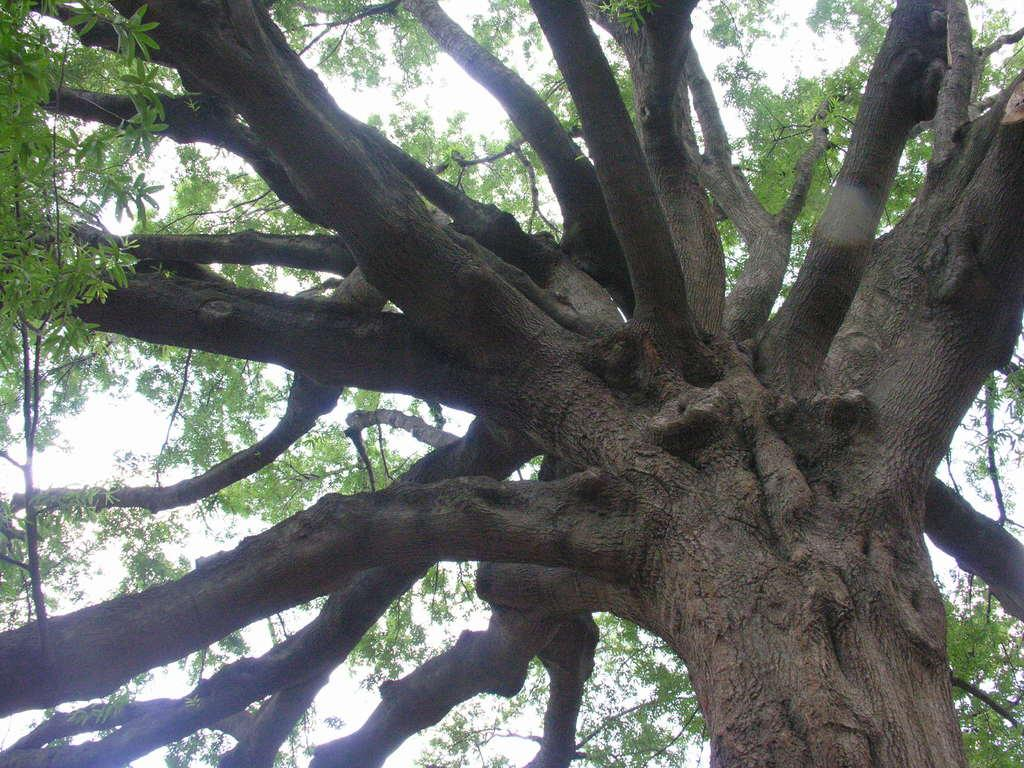What can be seen at the top of the image? The sky is visible in the image. What type of vegetation is present in the image? There is a tree in the image. What features can be observed on the tree? The tree has branches. How many eyes can be seen on the tree in the image? There are no eyes present on the tree in the image. 